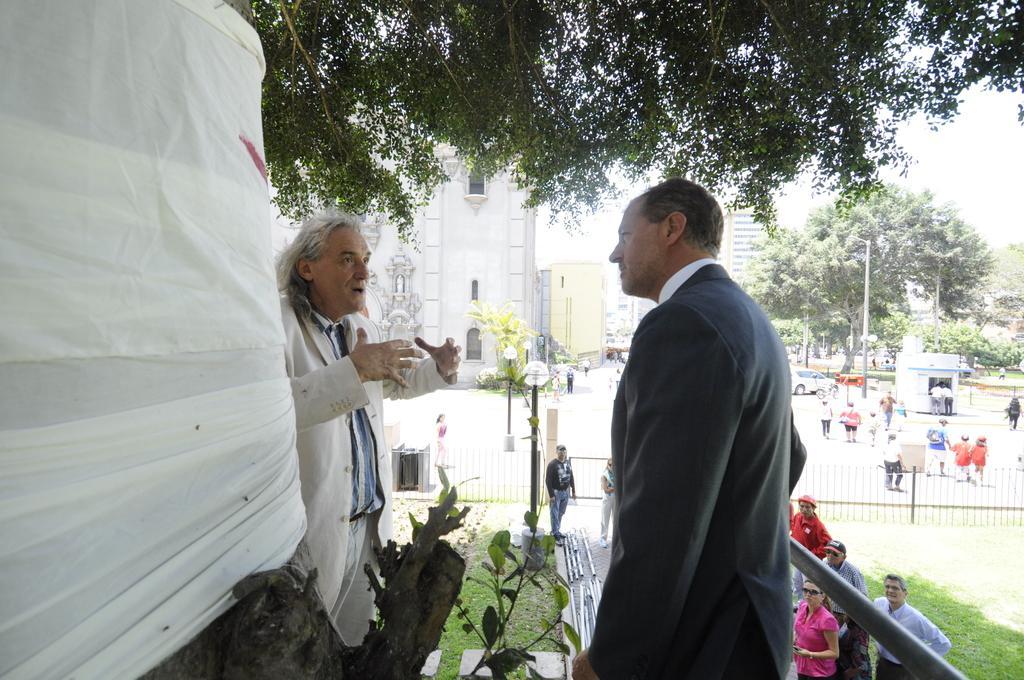How would you summarize this image in a sentence or two? On the left we can see a cloth tied to a tree and there are two men standing. In the background there are few persons,vehicle on the road,light poles,trees,buildings,windows,fence,grass and sky. 